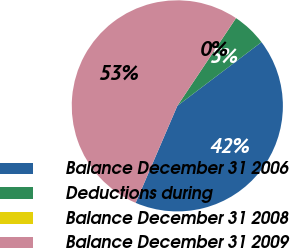Convert chart. <chart><loc_0><loc_0><loc_500><loc_500><pie_chart><fcel>Balance December 31 2006<fcel>Deductions during<fcel>Balance December 31 2008<fcel>Balance December 31 2009<nl><fcel>41.78%<fcel>5.3%<fcel>0.01%<fcel>52.92%<nl></chart> 